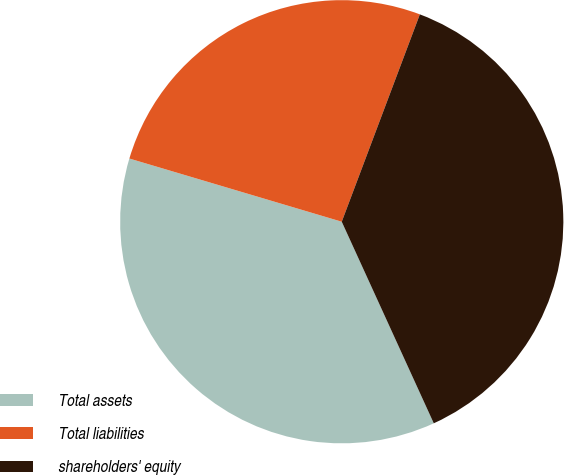<chart> <loc_0><loc_0><loc_500><loc_500><pie_chart><fcel>Total assets<fcel>Total liabilities<fcel>shareholders' equity<nl><fcel>36.42%<fcel>26.13%<fcel>37.45%<nl></chart> 